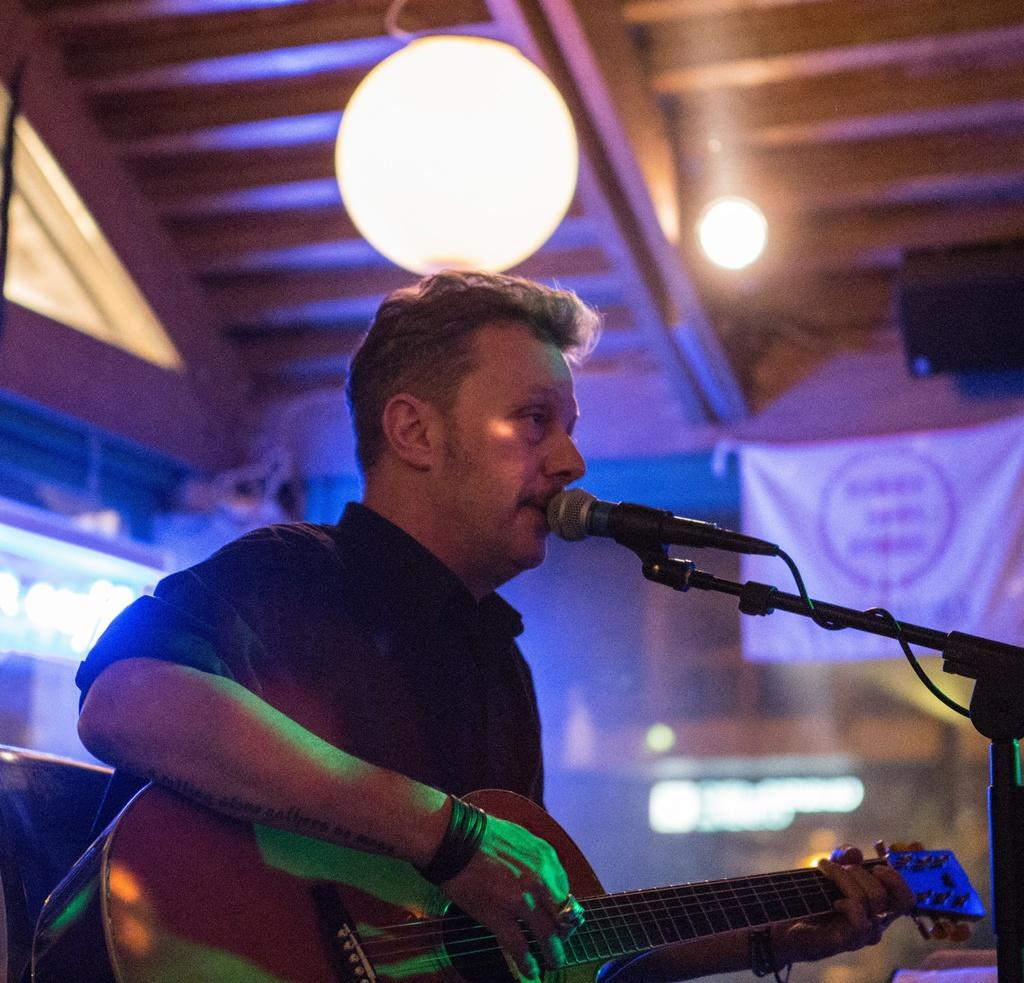What is the person in the image holding? The person is holding a guitar and a microphone. What might the person be doing in the image? The person might be performing or singing, given that they are holding a guitar and a microphone. What can be seen in the background of the image? There are lights and a roof visible in the background of the image. Can you see a giraffe swinging on a cloud in the image? No, there is no giraffe or cloud present in the image. 